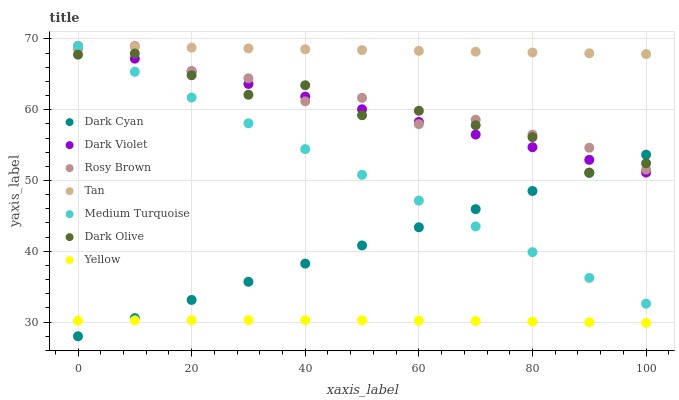Does Yellow have the minimum area under the curve?
Answer yes or no. Yes. Does Tan have the maximum area under the curve?
Answer yes or no. Yes. Does Rosy Brown have the minimum area under the curve?
Answer yes or no. No. Does Rosy Brown have the maximum area under the curve?
Answer yes or no. No. Is Tan the smoothest?
Answer yes or no. Yes. Is Dark Olive the roughest?
Answer yes or no. Yes. Is Rosy Brown the smoothest?
Answer yes or no. No. Is Rosy Brown the roughest?
Answer yes or no. No. Does Dark Cyan have the lowest value?
Answer yes or no. Yes. Does Rosy Brown have the lowest value?
Answer yes or no. No. Does Tan have the highest value?
Answer yes or no. Yes. Does Yellow have the highest value?
Answer yes or no. No. Is Yellow less than Dark Olive?
Answer yes or no. Yes. Is Rosy Brown greater than Yellow?
Answer yes or no. Yes. Does Dark Olive intersect Dark Violet?
Answer yes or no. Yes. Is Dark Olive less than Dark Violet?
Answer yes or no. No. Is Dark Olive greater than Dark Violet?
Answer yes or no. No. Does Yellow intersect Dark Olive?
Answer yes or no. No. 